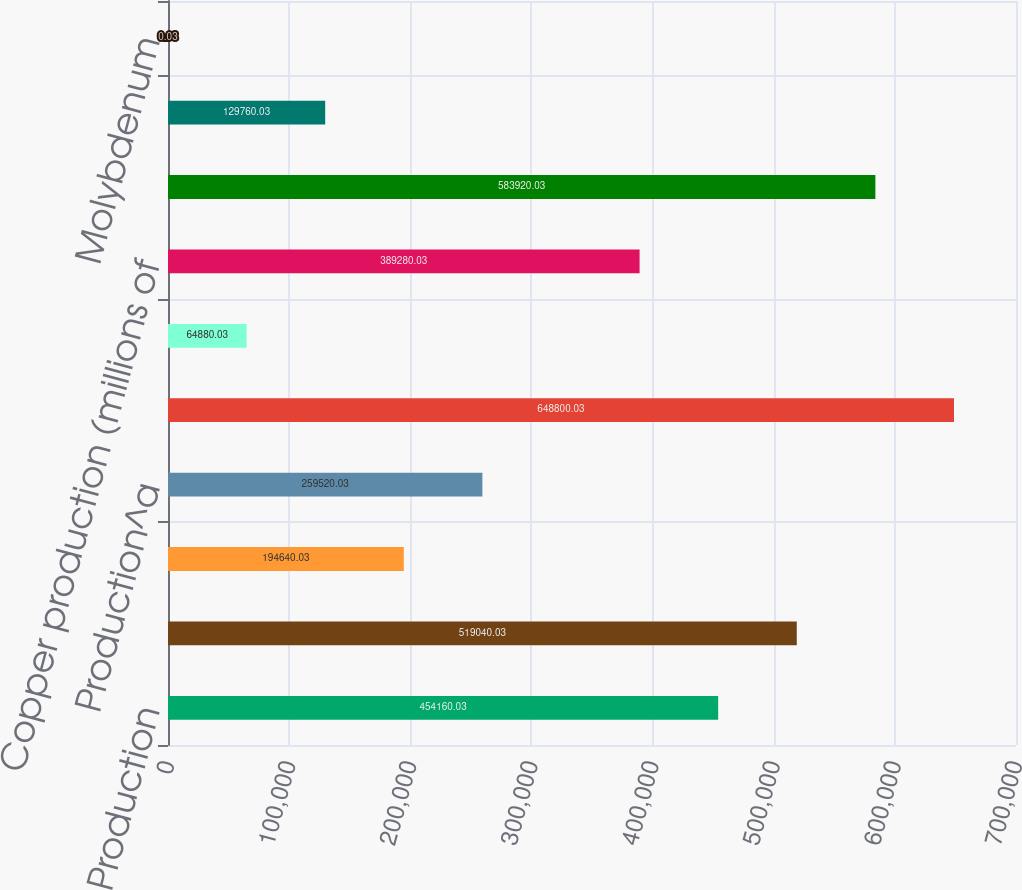Convert chart to OTSL. <chart><loc_0><loc_0><loc_500><loc_500><bar_chart><fcel>Production<fcel>Sales excluding purchases<fcel>Average realized price per<fcel>Production^a<fcel>Leach ore placed in stockpiles<fcel>Average copper ore grade<fcel>Copper production (millions of<fcel>Ore milled (metric tons per<fcel>Copper<fcel>Molybdenum<nl><fcel>454160<fcel>519040<fcel>194640<fcel>259520<fcel>648800<fcel>64880<fcel>389280<fcel>583920<fcel>129760<fcel>0.03<nl></chart> 